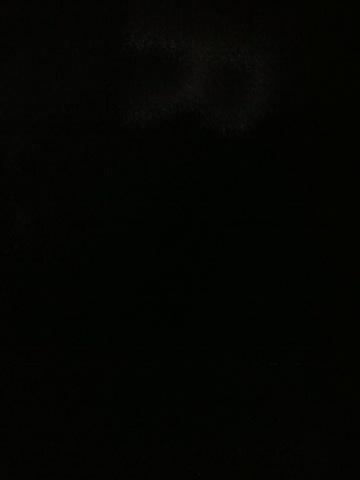What kind of computer is this? The image is too dark to clearly identify any details about the computer. Could you please provide a brighter image? Or perhaps describe some recognisable features about the computer? 